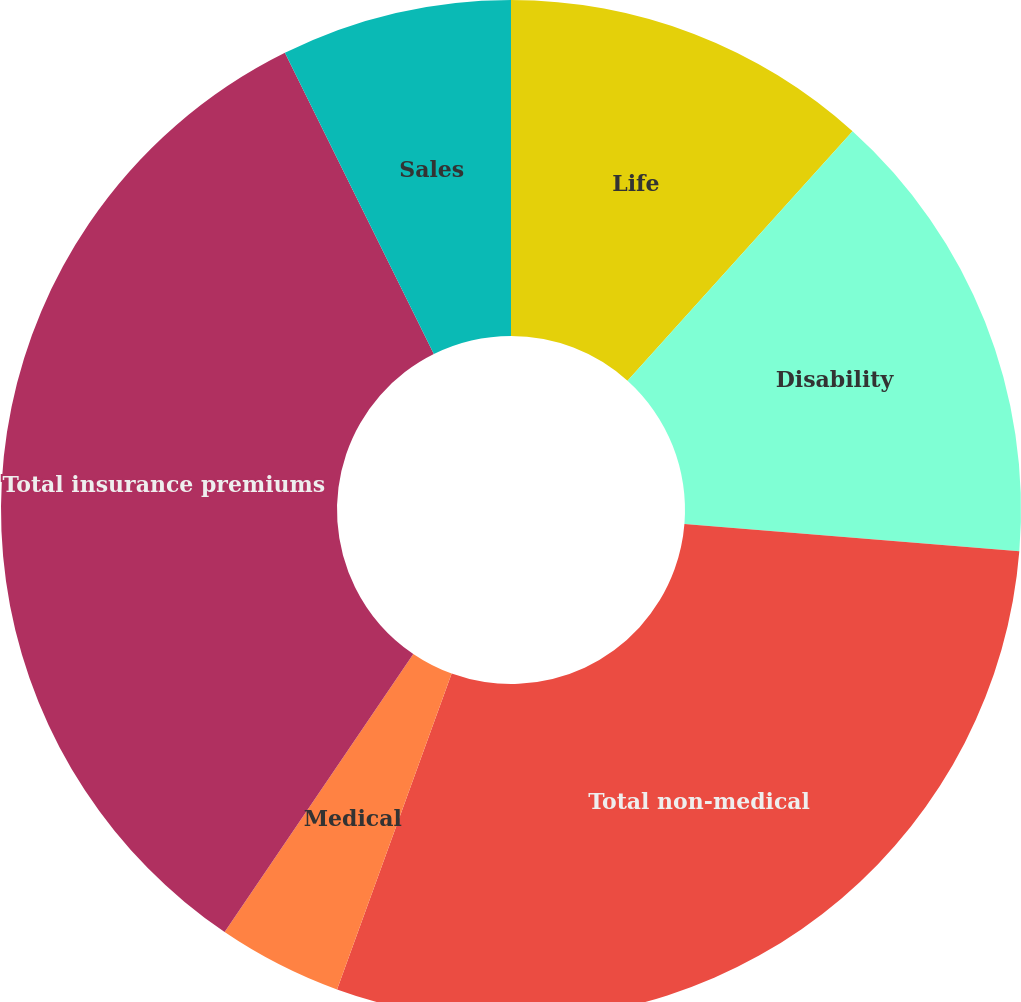Convert chart. <chart><loc_0><loc_0><loc_500><loc_500><pie_chart><fcel>Life<fcel>Disability<fcel>Total non-medical<fcel>Medical<fcel>Total insurance premiums<fcel>Sales<nl><fcel>11.68%<fcel>14.61%<fcel>29.25%<fcel>3.95%<fcel>33.2%<fcel>7.31%<nl></chart> 